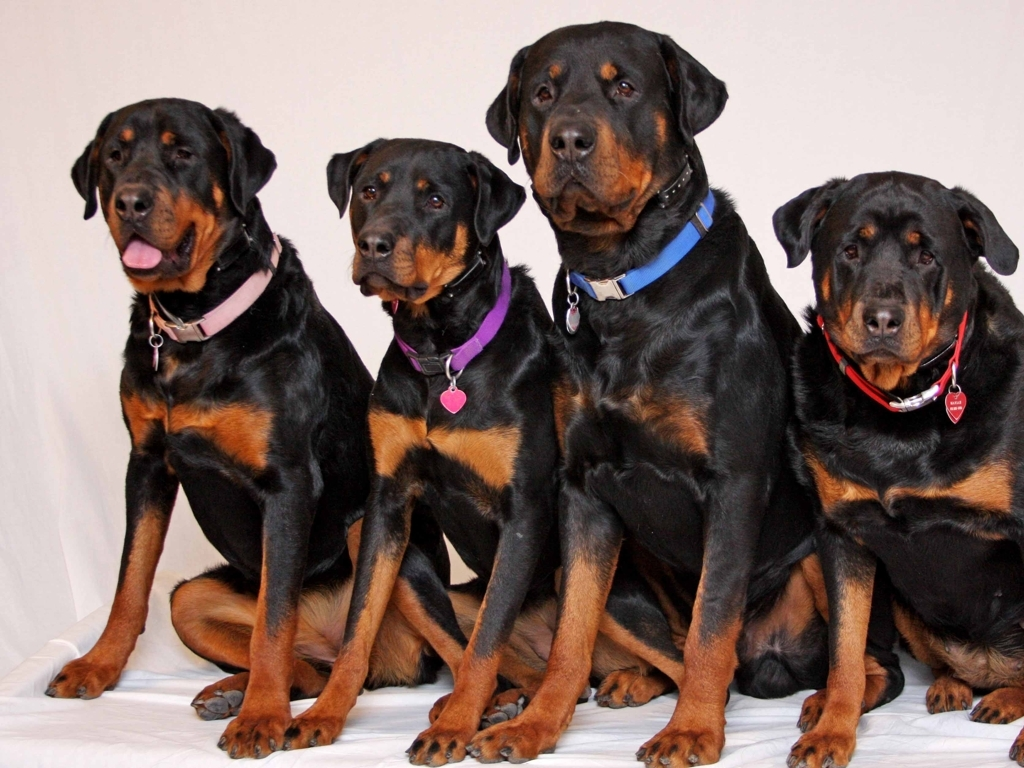What does the image feature?
A. Four Golden Retriever dogs wearing collars
B. Four Labrador dogs wearing collars
C. Four Doberman dogs wearing collars
D. Four Poodle dogs wearing collars
Answer with the option's letter from the given choices directly.
 C. 